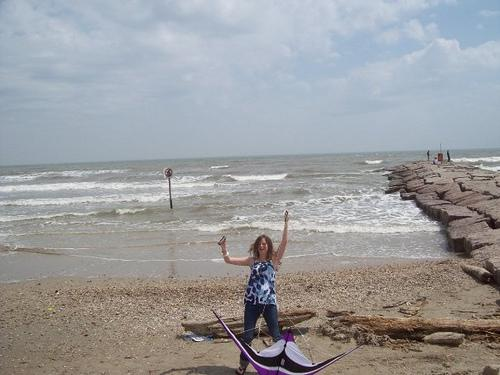What activity is she participating in? kite flying 